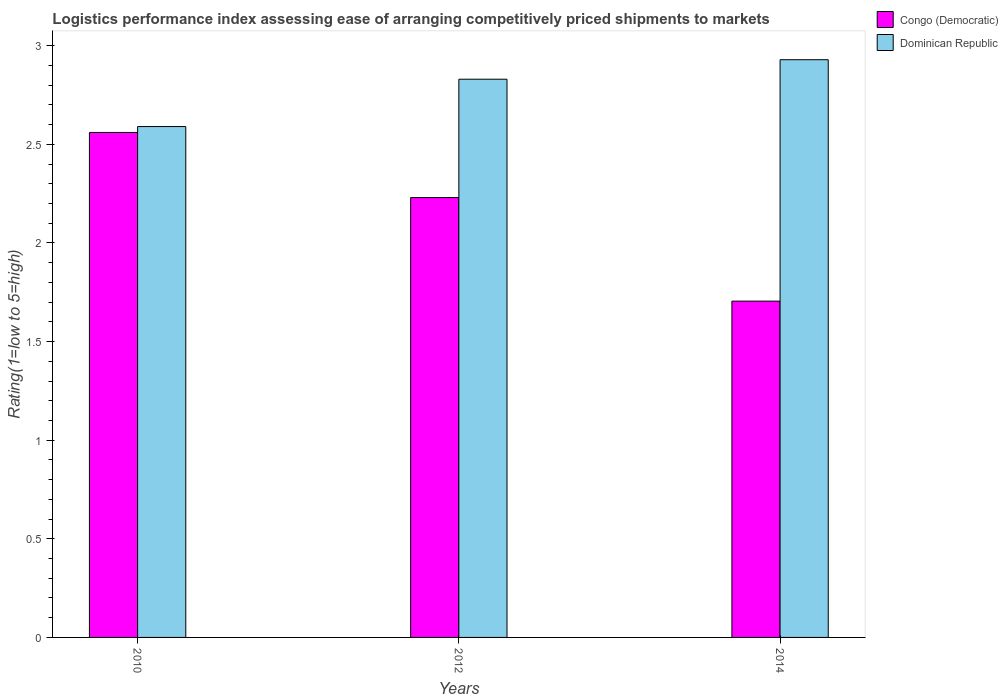How many different coloured bars are there?
Offer a terse response. 2. Are the number of bars per tick equal to the number of legend labels?
Your response must be concise. Yes. Are the number of bars on each tick of the X-axis equal?
Ensure brevity in your answer.  Yes. How many bars are there on the 2nd tick from the left?
Your answer should be compact. 2. What is the Logistic performance index in Dominican Republic in 2012?
Your answer should be compact. 2.83. Across all years, what is the maximum Logistic performance index in Dominican Republic?
Provide a succinct answer. 2.93. Across all years, what is the minimum Logistic performance index in Congo (Democratic)?
Provide a succinct answer. 1.7. In which year was the Logistic performance index in Dominican Republic minimum?
Offer a very short reply. 2010. What is the total Logistic performance index in Congo (Democratic) in the graph?
Make the answer very short. 6.49. What is the difference between the Logistic performance index in Dominican Republic in 2010 and that in 2014?
Provide a succinct answer. -0.34. What is the difference between the Logistic performance index in Dominican Republic in 2010 and the Logistic performance index in Congo (Democratic) in 2014?
Provide a short and direct response. 0.89. What is the average Logistic performance index in Dominican Republic per year?
Ensure brevity in your answer.  2.78. In the year 2014, what is the difference between the Logistic performance index in Dominican Republic and Logistic performance index in Congo (Democratic)?
Give a very brief answer. 1.22. What is the ratio of the Logistic performance index in Congo (Democratic) in 2010 to that in 2012?
Ensure brevity in your answer.  1.15. What is the difference between the highest and the second highest Logistic performance index in Dominican Republic?
Your response must be concise. 0.1. What is the difference between the highest and the lowest Logistic performance index in Congo (Democratic)?
Your response must be concise. 0.86. Is the sum of the Logistic performance index in Congo (Democratic) in 2010 and 2014 greater than the maximum Logistic performance index in Dominican Republic across all years?
Offer a terse response. Yes. What does the 1st bar from the left in 2010 represents?
Give a very brief answer. Congo (Democratic). What does the 2nd bar from the right in 2014 represents?
Your answer should be very brief. Congo (Democratic). How many bars are there?
Your answer should be very brief. 6. Are all the bars in the graph horizontal?
Ensure brevity in your answer.  No. What is the difference between two consecutive major ticks on the Y-axis?
Ensure brevity in your answer.  0.5. Are the values on the major ticks of Y-axis written in scientific E-notation?
Your answer should be very brief. No. Where does the legend appear in the graph?
Keep it short and to the point. Top right. What is the title of the graph?
Provide a succinct answer. Logistics performance index assessing ease of arranging competitively priced shipments to markets. Does "East Asia (developing only)" appear as one of the legend labels in the graph?
Give a very brief answer. No. What is the label or title of the Y-axis?
Keep it short and to the point. Rating(1=low to 5=high). What is the Rating(1=low to 5=high) in Congo (Democratic) in 2010?
Provide a succinct answer. 2.56. What is the Rating(1=low to 5=high) in Dominican Republic in 2010?
Offer a terse response. 2.59. What is the Rating(1=low to 5=high) of Congo (Democratic) in 2012?
Give a very brief answer. 2.23. What is the Rating(1=low to 5=high) of Dominican Republic in 2012?
Keep it short and to the point. 2.83. What is the Rating(1=low to 5=high) in Congo (Democratic) in 2014?
Make the answer very short. 1.7. What is the Rating(1=low to 5=high) of Dominican Republic in 2014?
Your response must be concise. 2.93. Across all years, what is the maximum Rating(1=low to 5=high) of Congo (Democratic)?
Give a very brief answer. 2.56. Across all years, what is the maximum Rating(1=low to 5=high) of Dominican Republic?
Your answer should be compact. 2.93. Across all years, what is the minimum Rating(1=low to 5=high) in Congo (Democratic)?
Give a very brief answer. 1.7. Across all years, what is the minimum Rating(1=low to 5=high) in Dominican Republic?
Offer a terse response. 2.59. What is the total Rating(1=low to 5=high) in Congo (Democratic) in the graph?
Ensure brevity in your answer.  6.5. What is the total Rating(1=low to 5=high) of Dominican Republic in the graph?
Your response must be concise. 8.35. What is the difference between the Rating(1=low to 5=high) in Congo (Democratic) in 2010 and that in 2012?
Your answer should be very brief. 0.33. What is the difference between the Rating(1=low to 5=high) in Dominican Republic in 2010 and that in 2012?
Offer a very short reply. -0.24. What is the difference between the Rating(1=low to 5=high) in Congo (Democratic) in 2010 and that in 2014?
Give a very brief answer. 0.85. What is the difference between the Rating(1=low to 5=high) in Dominican Republic in 2010 and that in 2014?
Offer a terse response. -0.34. What is the difference between the Rating(1=low to 5=high) of Congo (Democratic) in 2012 and that in 2014?
Give a very brief answer. 0.53. What is the difference between the Rating(1=low to 5=high) in Dominican Republic in 2012 and that in 2014?
Provide a succinct answer. -0.1. What is the difference between the Rating(1=low to 5=high) of Congo (Democratic) in 2010 and the Rating(1=low to 5=high) of Dominican Republic in 2012?
Make the answer very short. -0.27. What is the difference between the Rating(1=low to 5=high) of Congo (Democratic) in 2010 and the Rating(1=low to 5=high) of Dominican Republic in 2014?
Offer a terse response. -0.37. What is the difference between the Rating(1=low to 5=high) in Congo (Democratic) in 2012 and the Rating(1=low to 5=high) in Dominican Republic in 2014?
Provide a succinct answer. -0.7. What is the average Rating(1=low to 5=high) of Congo (Democratic) per year?
Your response must be concise. 2.17. What is the average Rating(1=low to 5=high) of Dominican Republic per year?
Ensure brevity in your answer.  2.78. In the year 2010, what is the difference between the Rating(1=low to 5=high) in Congo (Democratic) and Rating(1=low to 5=high) in Dominican Republic?
Provide a succinct answer. -0.03. In the year 2014, what is the difference between the Rating(1=low to 5=high) of Congo (Democratic) and Rating(1=low to 5=high) of Dominican Republic?
Provide a succinct answer. -1.22. What is the ratio of the Rating(1=low to 5=high) in Congo (Democratic) in 2010 to that in 2012?
Your answer should be very brief. 1.15. What is the ratio of the Rating(1=low to 5=high) of Dominican Republic in 2010 to that in 2012?
Provide a short and direct response. 0.92. What is the ratio of the Rating(1=low to 5=high) of Congo (Democratic) in 2010 to that in 2014?
Offer a terse response. 1.5. What is the ratio of the Rating(1=low to 5=high) in Dominican Republic in 2010 to that in 2014?
Ensure brevity in your answer.  0.88. What is the ratio of the Rating(1=low to 5=high) in Congo (Democratic) in 2012 to that in 2014?
Offer a very short reply. 1.31. What is the ratio of the Rating(1=low to 5=high) of Dominican Republic in 2012 to that in 2014?
Provide a succinct answer. 0.97. What is the difference between the highest and the second highest Rating(1=low to 5=high) in Congo (Democratic)?
Offer a terse response. 0.33. What is the difference between the highest and the second highest Rating(1=low to 5=high) in Dominican Republic?
Offer a very short reply. 0.1. What is the difference between the highest and the lowest Rating(1=low to 5=high) in Congo (Democratic)?
Your response must be concise. 0.85. What is the difference between the highest and the lowest Rating(1=low to 5=high) of Dominican Republic?
Offer a very short reply. 0.34. 